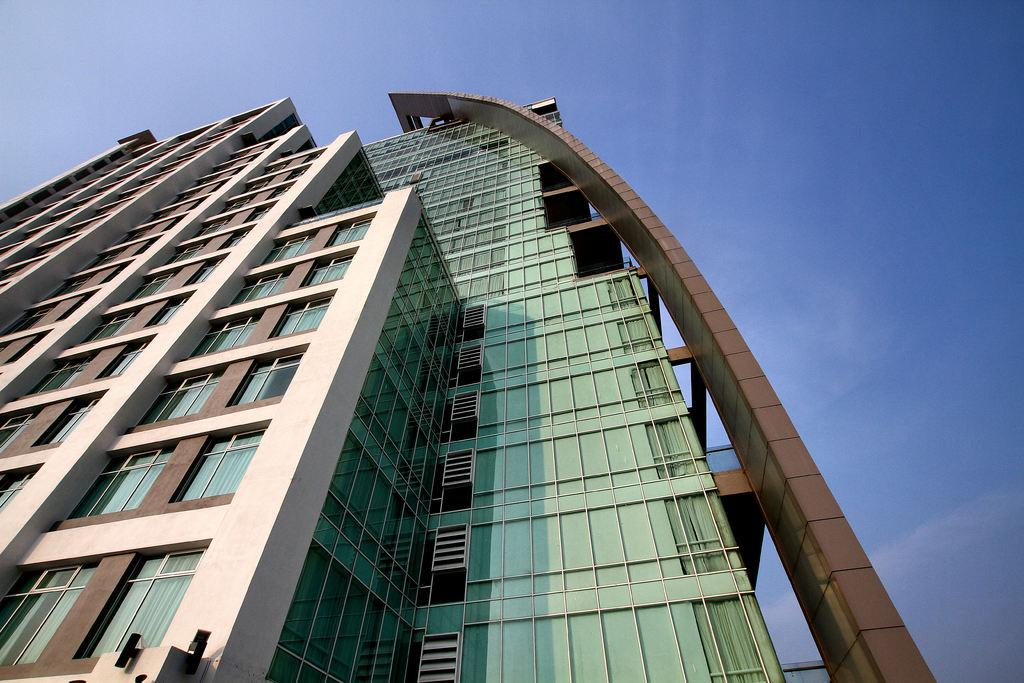What structure is present in the image? There is a building in the image. What feature can be observed on the building? The building has windows. What is visible in the background of the image? The sky is visible in the background of the image. Can you see the secretary using a whistle on the face of the building in the image? There is no secretary or whistle present on the face of the building in the image. 